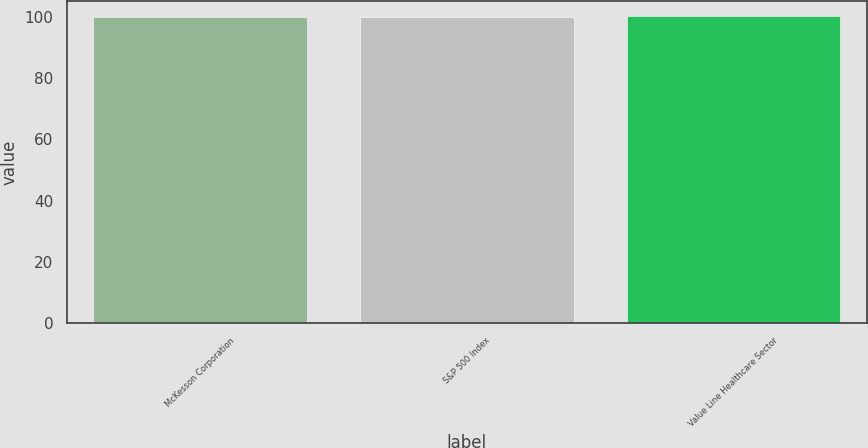Convert chart. <chart><loc_0><loc_0><loc_500><loc_500><bar_chart><fcel>McKesson Corporation<fcel>S&P 500 Index<fcel>Value Line Healthcare Sector<nl><fcel>100<fcel>100.1<fcel>100.2<nl></chart> 